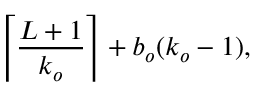<formula> <loc_0><loc_0><loc_500><loc_500>\left \lceil \frac { L + 1 } { k _ { o } } \right \rceil + b _ { o } ( k _ { o } - 1 ) ,</formula> 